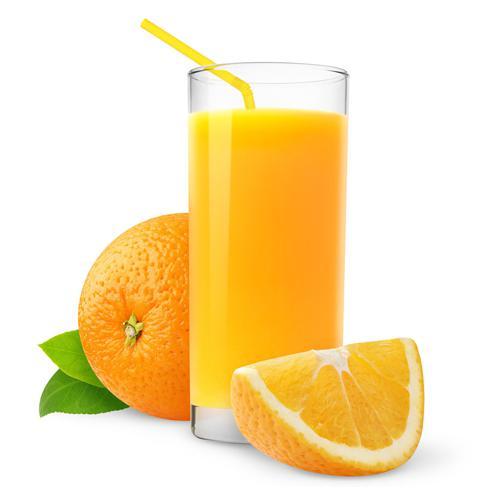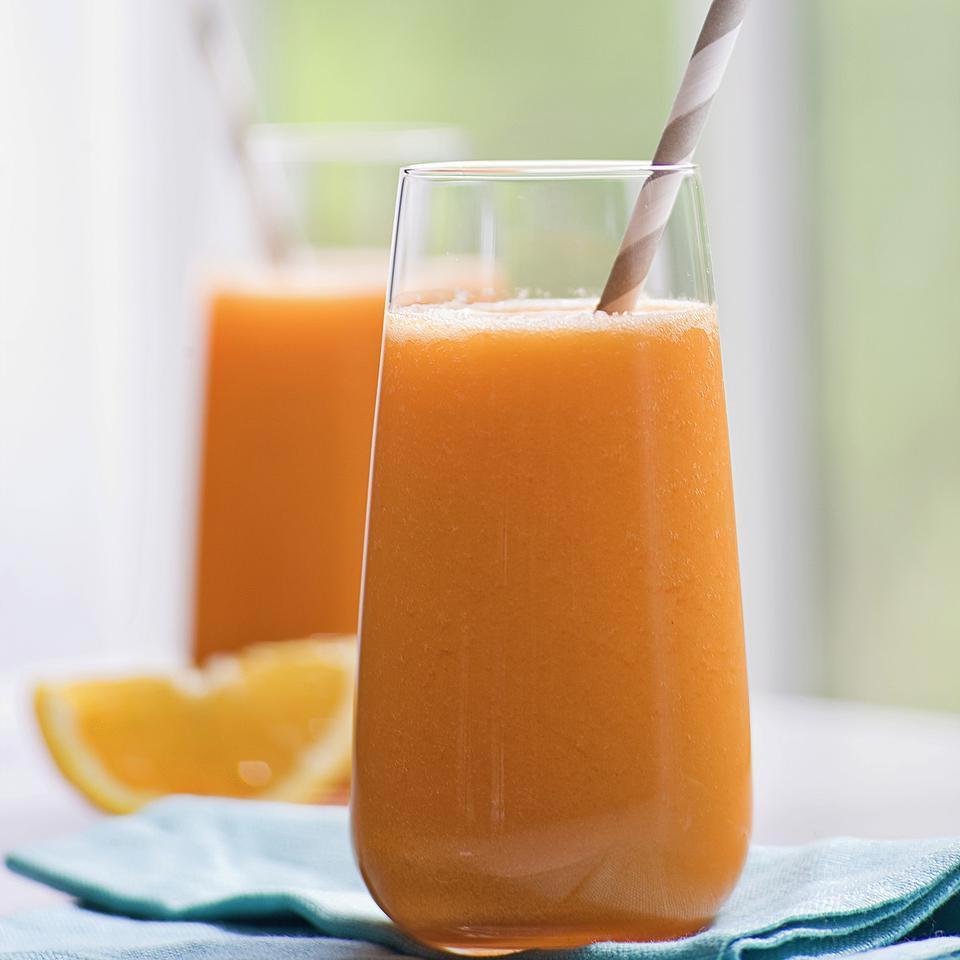The first image is the image on the left, the second image is the image on the right. Given the left and right images, does the statement "Glasses of orange juice without straws in them are present in at least one image." hold true? Answer yes or no. No. The first image is the image on the left, the second image is the image on the right. For the images shown, is this caption "An orange WEDGE rests against a glass of juice." true? Answer yes or no. Yes. 